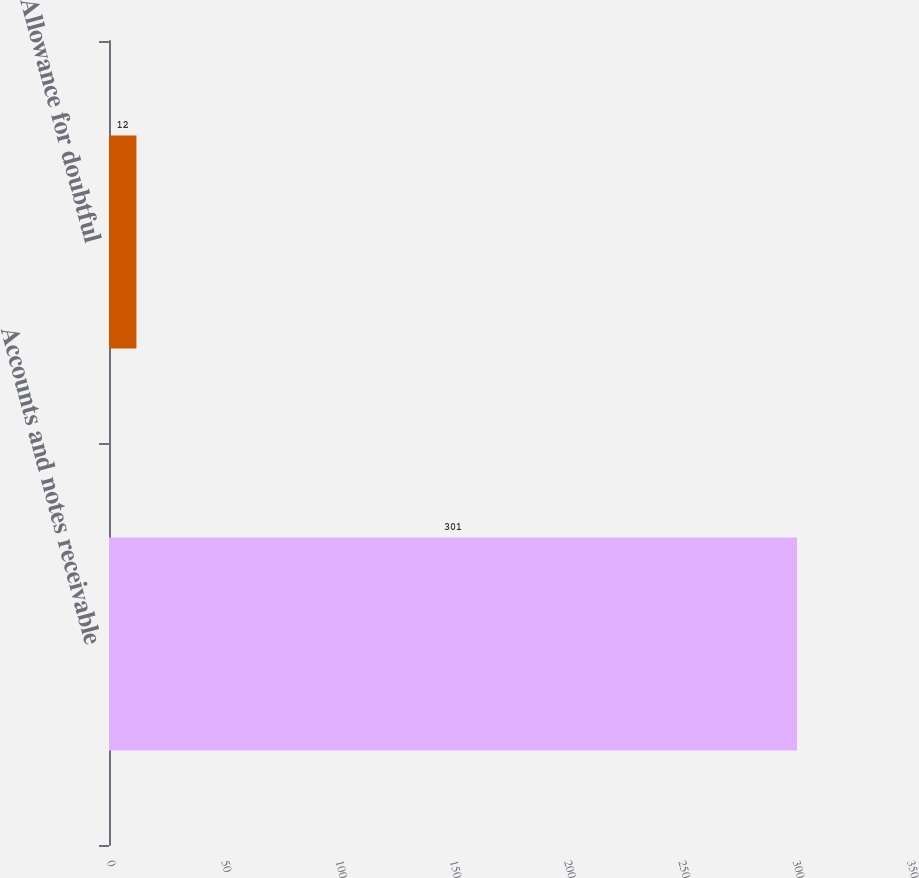Convert chart to OTSL. <chart><loc_0><loc_0><loc_500><loc_500><bar_chart><fcel>Accounts and notes receivable<fcel>Allowance for doubtful<nl><fcel>301<fcel>12<nl></chart> 